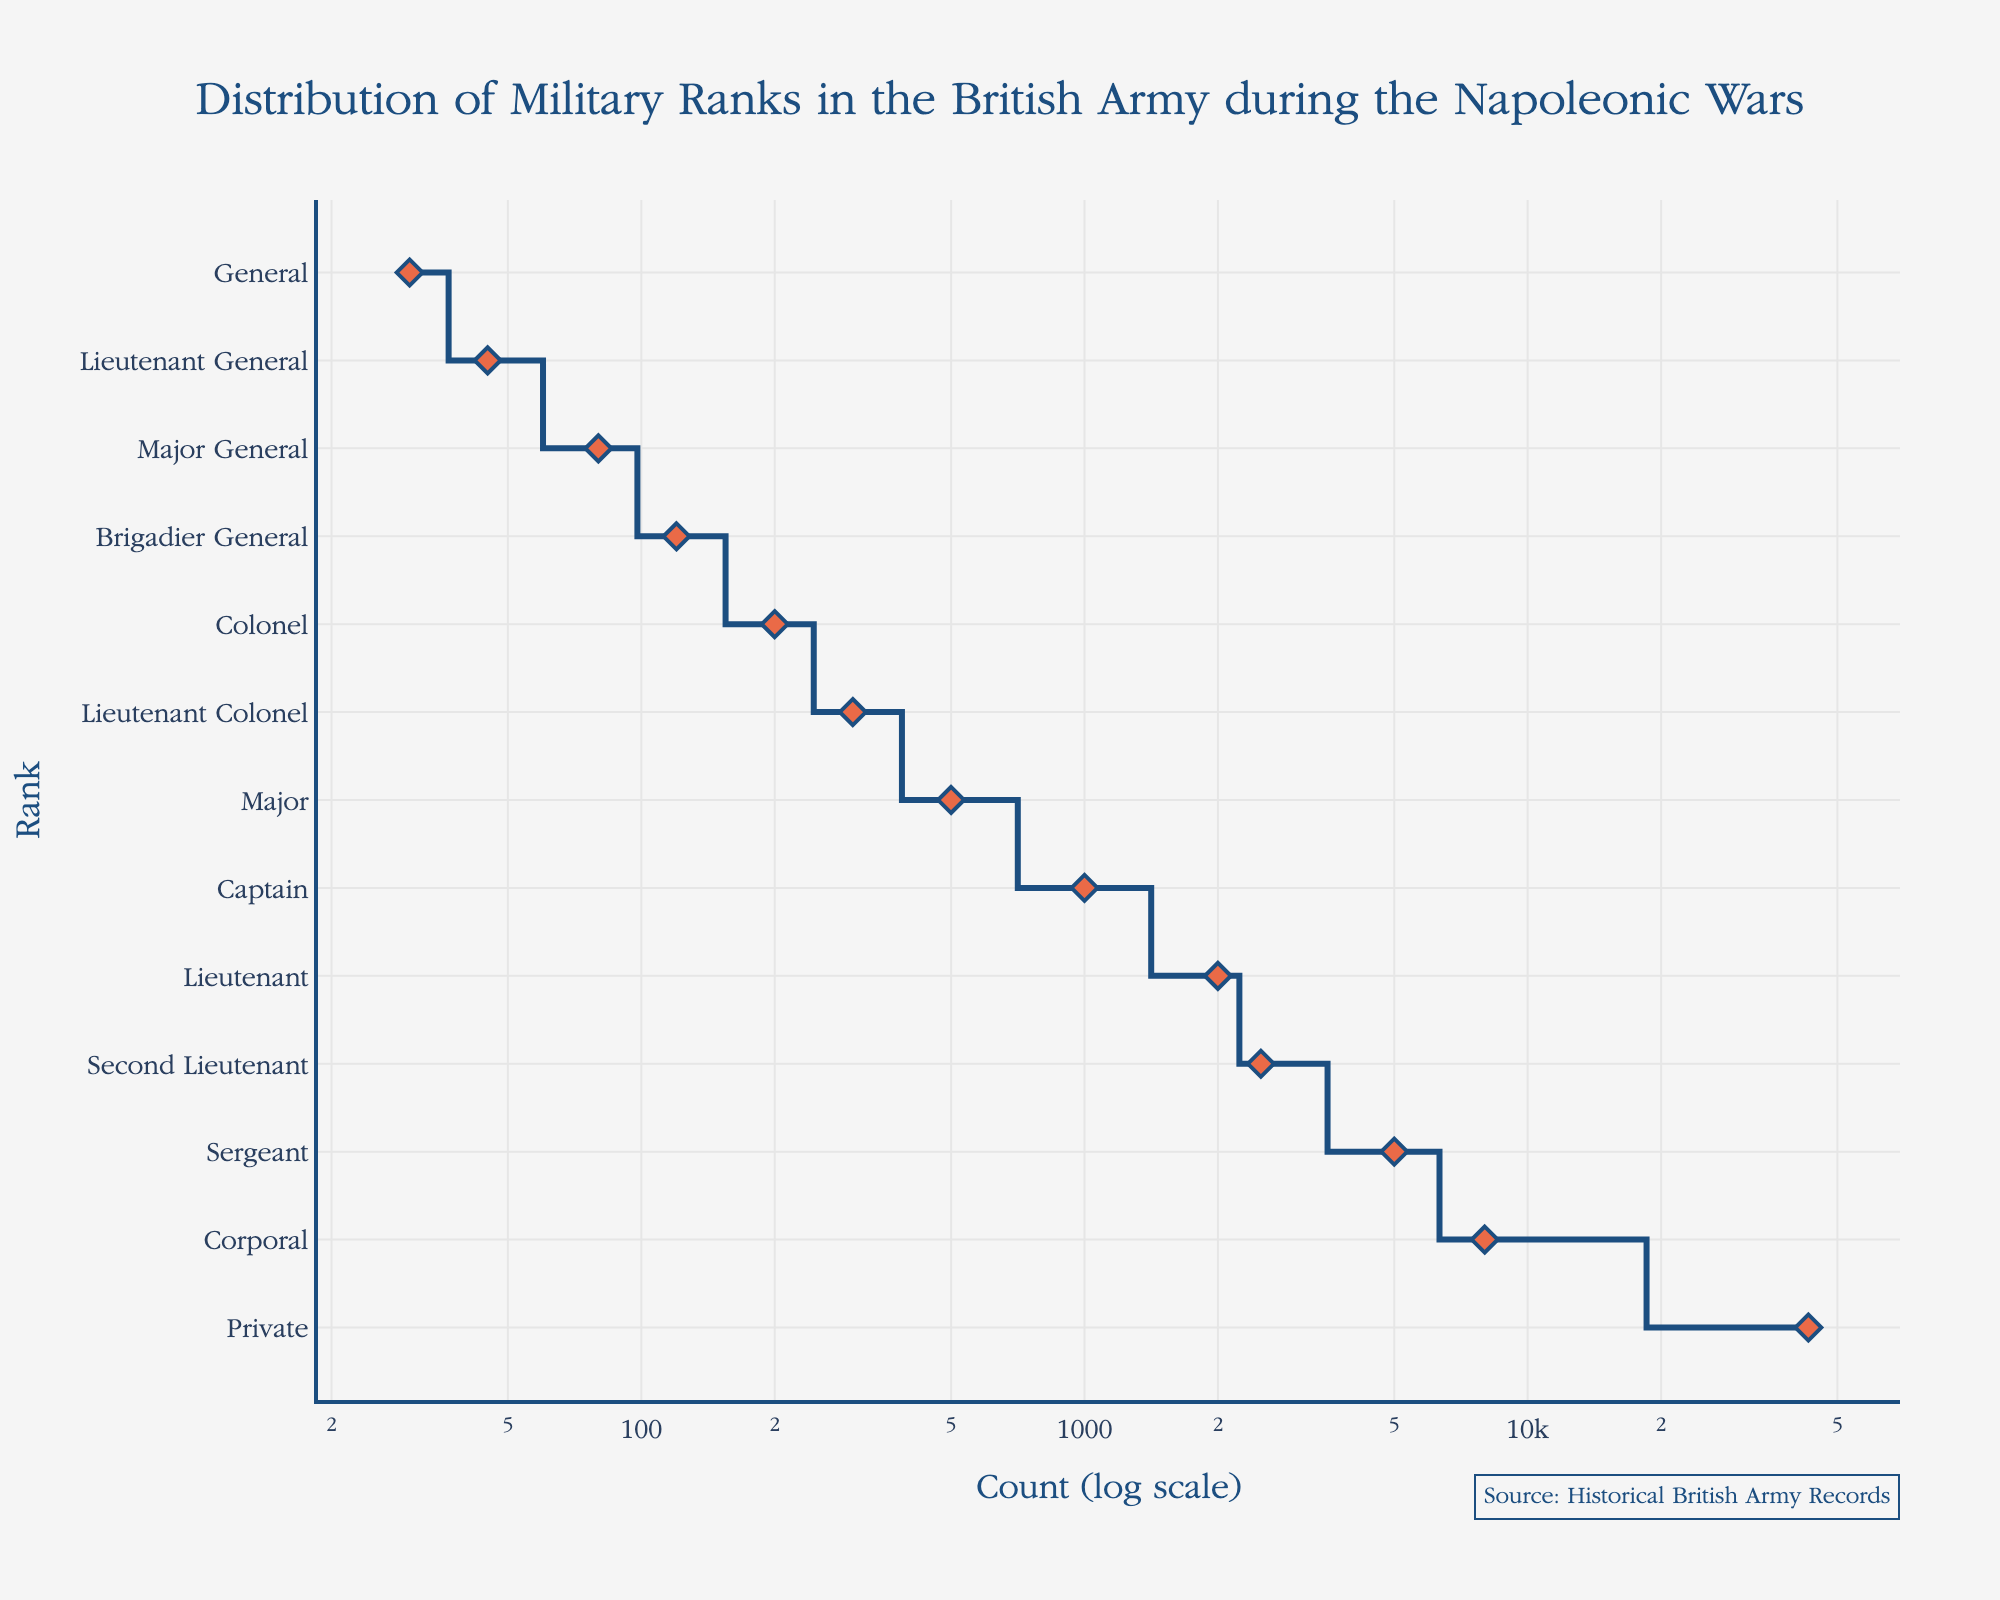Which rank has the highest count during the Napoleonic Wars? The rank with the highest count is the one at the top of the y-axis with the largest value on the x-axis, which is "Private" with 43,000.
Answer: Private Which rank has the smallest count? The rank with the smallest count is the one at the bottom of the y-axis with the smallest value on the x-axis, which is "General" with 30.
Answer: General What's the difference in count between a Lieutenant and a Lieutenant Colonel? Look at the y-axis to identify "Lieutenant" and "Lieutenant Colonel," then note their counts: 2000 for "Lieutenant" and 300 for "Lieutenant Colonel". The difference is 2000 - 300 = 1700.
Answer: 1700 Which rank falls just below "Colonel" in terms of count? Identify "Colonel" on the y-axis, with a count of 200. The next rank below "Colonel" is "Brigadier General" with a count of 120.
Answer: Brigadier General How many ranks are present in the British Army distribution during the Napoleonic Wars? Count the number of unique ranks listed along the y-axis, which total to 13.
Answer: 13 How many times greater is the count for Captains compared to Majors? Look at the counts for "Captain" (1000) and "Major" (500). The count for Captains is 1000 / 500 = 2 times greater than that of Majors.
Answer: 2 What is the average count for Generals of all ranks (combining General, Lieutenant General, Major General, and Brigadier General)? The counts for Generals are: General (30), Lieutenant General (45), Major General (80), Brigadier General (120). Average = (30 + 45 + 80 + 120) / 4 = 275 / 4 = 68.75.
Answer: 68.75 Which rank has a count that is equal to the sum of the counts of Generals and Lieutenants? Add up the counts for General (30), Lieutenant General (45), Major General (80), and Brigadier General (120) to get 275. The ranks whose counts are equal or close to 275 are "Lieutenant Colonel" with 300 and "Major" with 500. None match exactly, but "Lieutenant Colonel" is the closest.
Answer: Lieutenant Colonel 